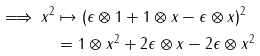Convert formula to latex. <formula><loc_0><loc_0><loc_500><loc_500>\implies x ^ { 2 } & \mapsto ( \epsilon \otimes 1 + 1 \otimes x - \epsilon \otimes x ) ^ { 2 } \\ & = 1 \otimes x ^ { 2 } + 2 \epsilon \otimes x - 2 \epsilon \otimes x ^ { 2 }</formula> 